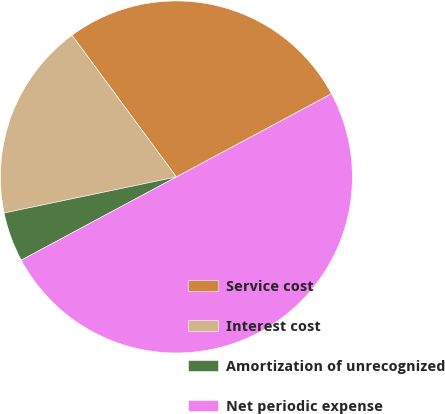Convert chart to OTSL. <chart><loc_0><loc_0><loc_500><loc_500><pie_chart><fcel>Service cost<fcel>Interest cost<fcel>Amortization of unrecognized<fcel>Net periodic expense<nl><fcel>27.27%<fcel>18.18%<fcel>4.55%<fcel>50.0%<nl></chart> 